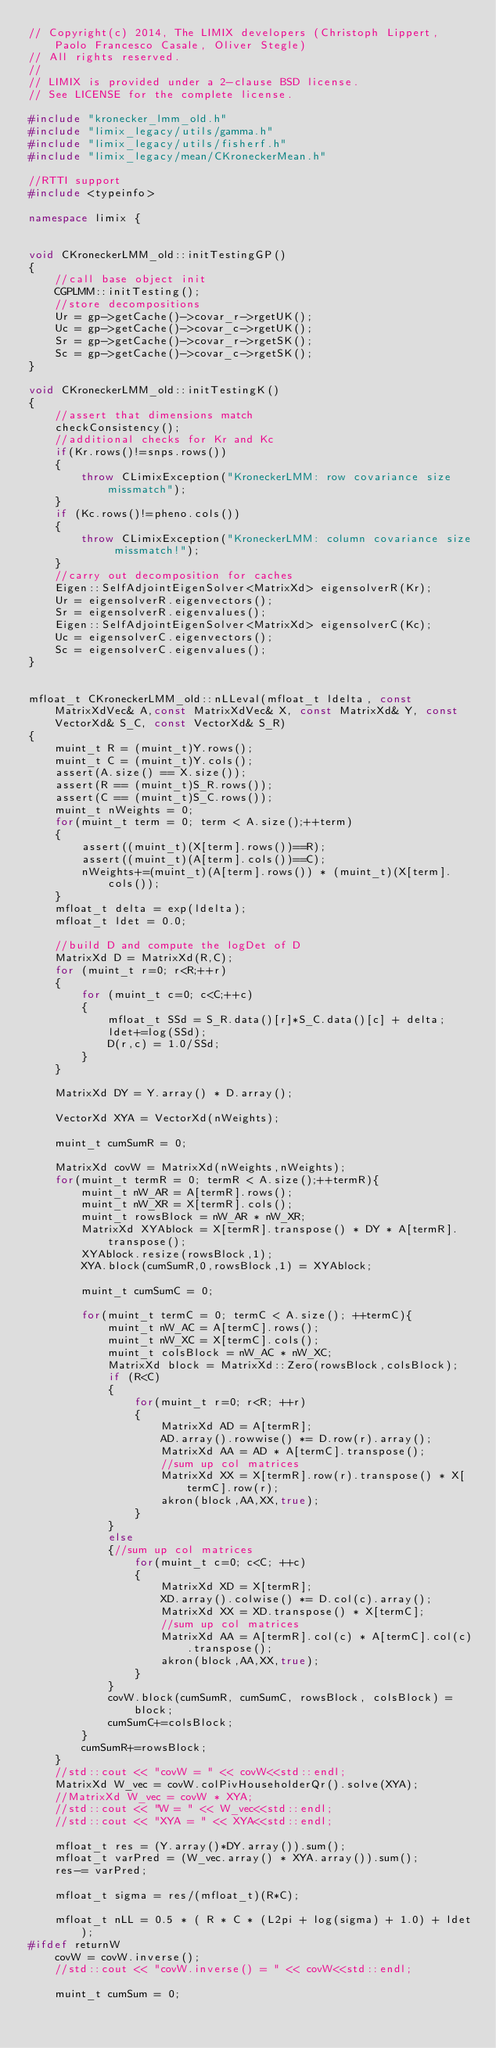Convert code to text. <code><loc_0><loc_0><loc_500><loc_500><_C++_>// Copyright(c) 2014, The LIMIX developers (Christoph Lippert, Paolo Francesco Casale, Oliver Stegle)
// All rights reserved.
//
// LIMIX is provided under a 2-clause BSD license.
// See LICENSE for the complete license.

#include "kronecker_lmm_old.h"
#include "limix_legacy/utils/gamma.h"
#include "limix_legacy/utils/fisherf.h"
#include "limix_legacy/mean/CKroneckerMean.h"

//RTTI support
#include <typeinfo>

namespace limix {


void CKroneckerLMM_old::initTestingGP()
{
	//call base object init
	CGPLMM::initTesting();
	//store decompositions
	Ur = gp->getCache()->covar_r->rgetUK();
	Uc = gp->getCache()->covar_c->rgetUK();
	Sr = gp->getCache()->covar_r->rgetSK();
	Sc = gp->getCache()->covar_c->rgetSK();
}

void CKroneckerLMM_old::initTestingK()
{
	//assert that dimensions match
	checkConsistency();
	//additional checks for Kr and Kc
	if(Kr.rows()!=snps.rows())
	{
		throw CLimixException("KroneckerLMM: row covariance size missmatch");
	}
	if (Kc.rows()!=pheno.cols())
	{
		throw CLimixException("KroneckerLMM: column covariance size missmatch!");
	}
	//carry out decomposition for caches
	Eigen::SelfAdjointEigenSolver<MatrixXd> eigensolverR(Kr);
	Ur = eigensolverR.eigenvectors();
	Sr = eigensolverR.eigenvalues();
	Eigen::SelfAdjointEigenSolver<MatrixXd> eigensolverC(Kc);
	Uc = eigensolverC.eigenvectors();
	Sc = eigensolverC.eigenvalues();
}


mfloat_t CKroneckerLMM_old::nLLeval(mfloat_t ldelta, const MatrixXdVec& A,const MatrixXdVec& X, const MatrixXd& Y, const VectorXd& S_C, const VectorXd& S_R)
{
	muint_t R = (muint_t)Y.rows();
	muint_t C = (muint_t)Y.cols();
	assert(A.size() == X.size());
	assert(R == (muint_t)S_R.rows());
	assert(C == (muint_t)S_C.rows());
	muint_t nWeights = 0;
	for(muint_t term = 0; term < A.size();++term)
	{
		assert((muint_t)(X[term].rows())==R);
		assert((muint_t)(A[term].cols())==C);
		nWeights+=(muint_t)(A[term].rows()) * (muint_t)(X[term].cols());
	}
	mfloat_t delta = exp(ldelta);
	mfloat_t ldet = 0.0;

	//build D and compute the logDet of D
	MatrixXd D = MatrixXd(R,C);
	for (muint_t r=0; r<R;++r)
	{
		for (muint_t c=0; c<C;++c)
		{
			mfloat_t SSd = S_R.data()[r]*S_C.data()[c] + delta;
			ldet+=log(SSd);
			D(r,c) = 1.0/SSd;
		}
	}

	MatrixXd DY = Y.array() * D.array();

	VectorXd XYA = VectorXd(nWeights);

	muint_t cumSumR = 0;

	MatrixXd covW = MatrixXd(nWeights,nWeights);
	for(muint_t termR = 0; termR < A.size();++termR){
		muint_t nW_AR = A[termR].rows();
		muint_t nW_XR = X[termR].cols();
		muint_t rowsBlock = nW_AR * nW_XR;
		MatrixXd XYAblock = X[termR].transpose() * DY * A[termR].transpose();
		XYAblock.resize(rowsBlock,1);
		XYA.block(cumSumR,0,rowsBlock,1) = XYAblock;

		muint_t cumSumC = 0;

		for(muint_t termC = 0; termC < A.size(); ++termC){
			muint_t nW_AC = A[termC].rows();
			muint_t nW_XC = X[termC].cols();
			muint_t colsBlock = nW_AC * nW_XC;
			MatrixXd block = MatrixXd::Zero(rowsBlock,colsBlock);
			if (R<C)
			{
				for(muint_t r=0; r<R; ++r)
				{
					MatrixXd AD = A[termR];
					AD.array().rowwise() *= D.row(r).array();
					MatrixXd AA = AD * A[termC].transpose();
					//sum up col matrices
					MatrixXd XX = X[termR].row(r).transpose() * X[termC].row(r);
					akron(block,AA,XX,true);
				}
			}
			else
			{//sum up col matrices
				for(muint_t c=0; c<C; ++c)
				{
					MatrixXd XD = X[termR];
					XD.array().colwise() *= D.col(c).array();
					MatrixXd XX = XD.transpose() * X[termC];
					//sum up col matrices
					MatrixXd AA = A[termR].col(c) * A[termC].col(c).transpose();
					akron(block,AA,XX,true);
				}
			}
			covW.block(cumSumR, cumSumC, rowsBlock, colsBlock) = block;
			cumSumC+=colsBlock;
		}
		cumSumR+=rowsBlock;
	}
	//std::cout << "covW = " << covW<<std::endl;
	MatrixXd W_vec = covW.colPivHouseholderQr().solve(XYA);
	//MatrixXd W_vec = covW * XYA;
	//std::cout << "W = " << W_vec<<std::endl;
	//std::cout << "XYA = " << XYA<<std::endl;

	mfloat_t res = (Y.array()*DY.array()).sum();
	mfloat_t varPred = (W_vec.array() * XYA.array()).sum();
	res-= varPred;

	mfloat_t sigma = res/(mfloat_t)(R*C);

	mfloat_t nLL = 0.5 * ( R * C * (L2pi + log(sigma) + 1.0) + ldet);
#ifdef returnW
	covW = covW.inverse();
	//std::cout << "covW.inverse() = " << covW<<std::endl;

	muint_t cumSum = 0;</code> 